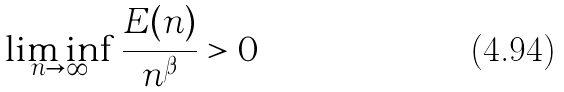Convert formula to latex. <formula><loc_0><loc_0><loc_500><loc_500>\liminf _ { n \rightarrow \infty } \frac { E ( n ) } { n ^ { \beta } } > 0</formula> 